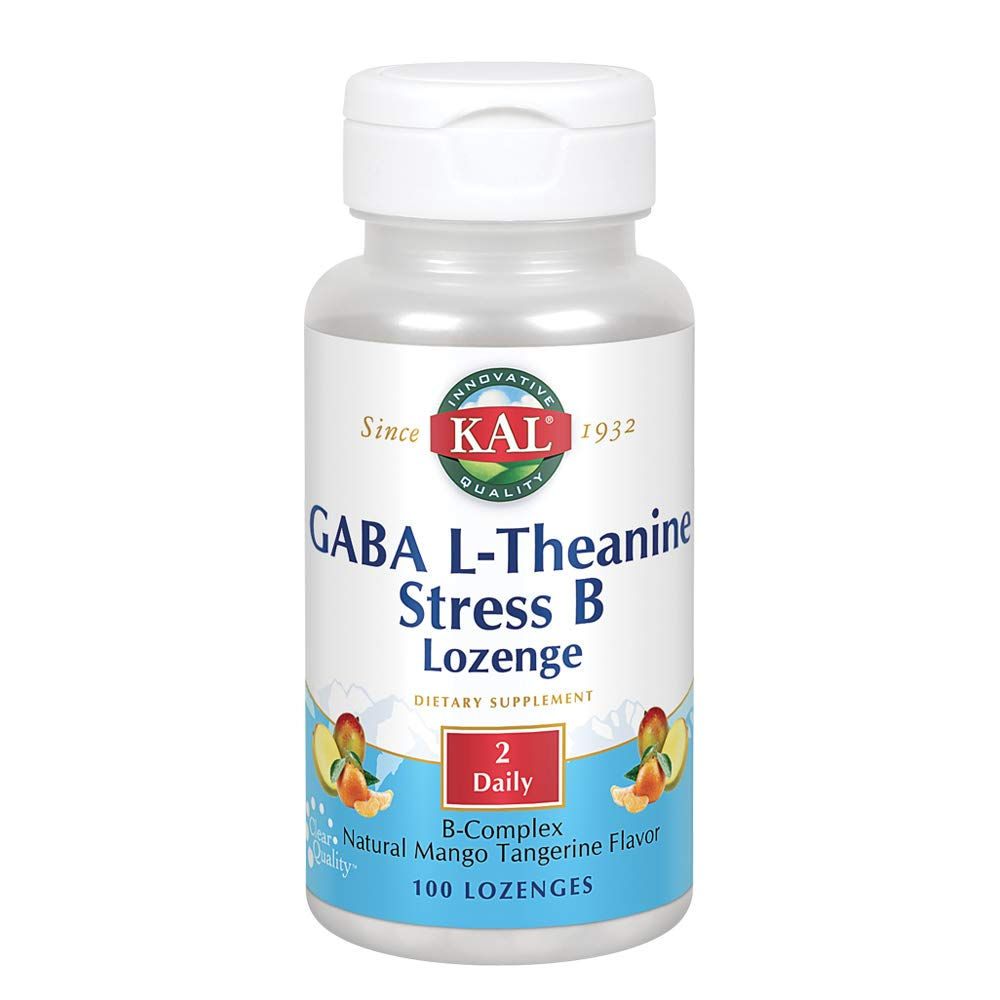Given the information on the label, what might be the potential benefits of the supplement, and how could they relate to the ingredients listed (GABA, L-Theanine, and B-Complex)? The potential benefits of the supplement, based on the label, suggest it could help relieve stress and enhance mental relaxation and focus. GABA (gamma-aminobutyric acid) acts as a neurotransmitter that may reduce nervous system activity, promoting a calming effect. L-Theanine, an amino acid found in tea, is known for fostering relaxation without inducing drowsiness. B-Complex vitamins, on the other hand, are recognized for boosting energy levels and supporting brain function. Hence, the blend of these ingredients could synergistically contribute to stress reduction, relaxation, and cognitive health. Additionally, the inclusion of the natural mango tangerine flavor may enhance the palatability of the supplement, making it easier to take regularly. 